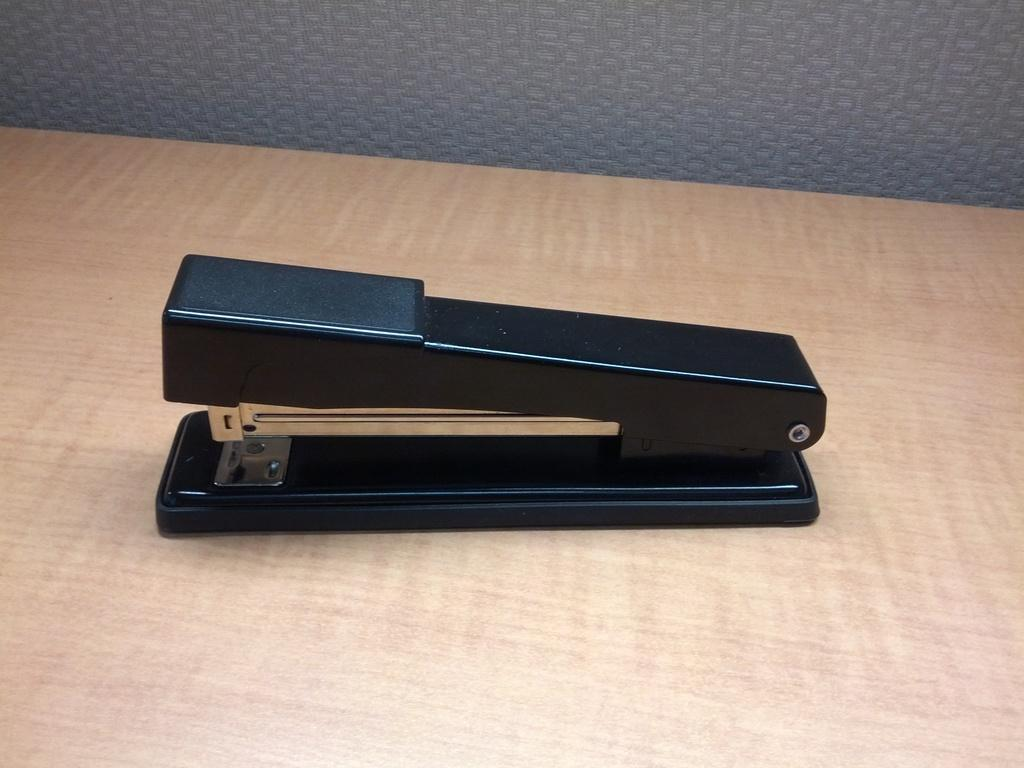Where was the image taken? The image was taken indoors. What can be seen in the background of the image? There is a wall in the background of the image. What piece of furniture is present in the image? There is a table in the image. What object is on the table? A stapler is present on the table. What type of prose is being read by the visitor in the image? There is no visitor present in the image, and no prose is being read. 